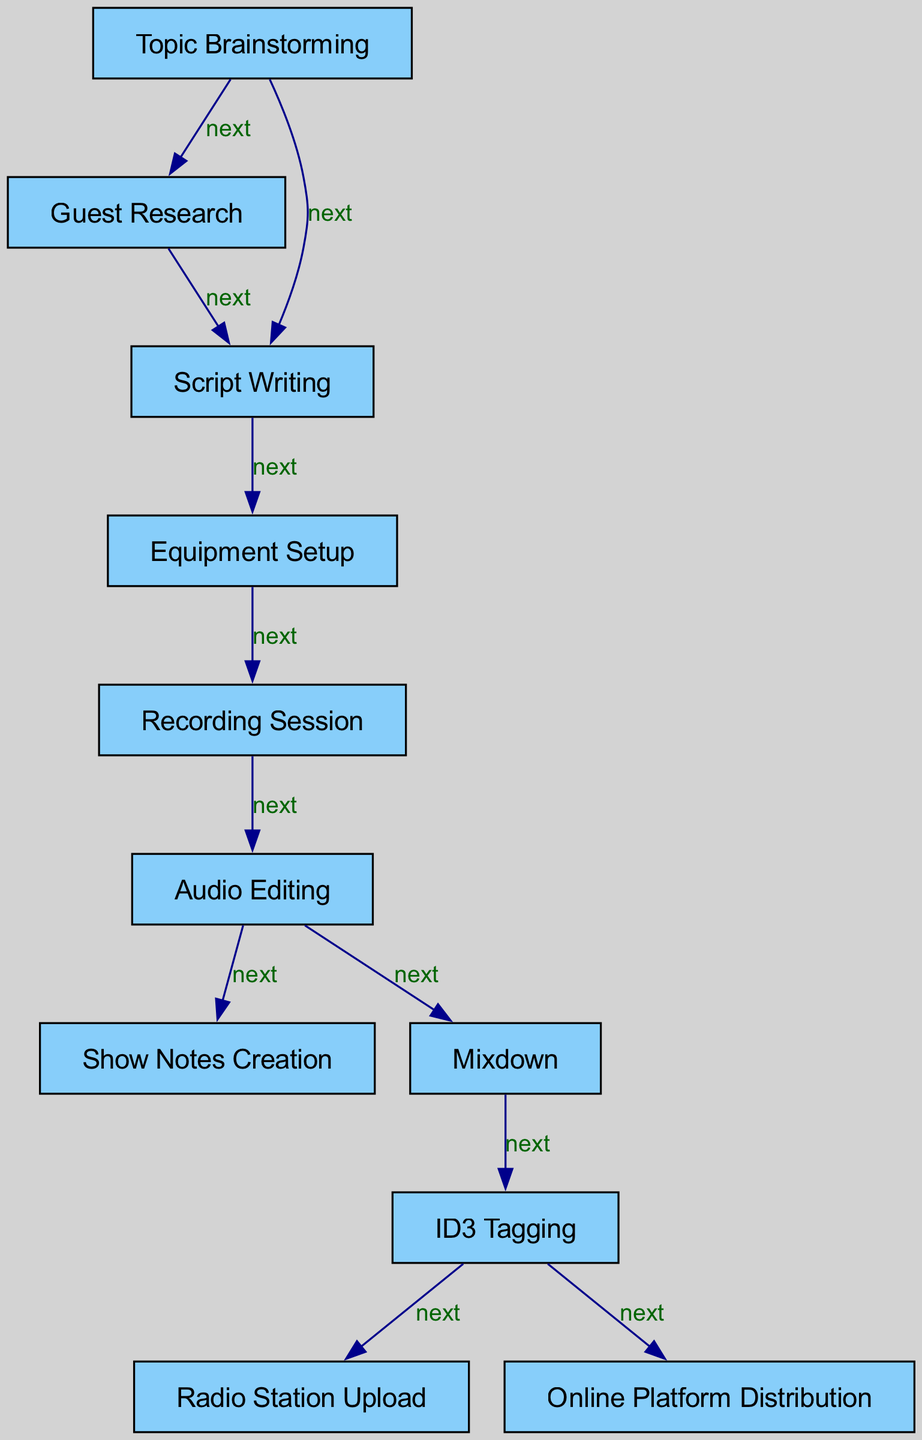What’s the total number of nodes in the diagram? To find the total number of nodes, we can simply count all the unique processes involved in the podcast production, which includes Topic Brainstorming, Guest Research, Script Writing, Equipment Setup, Recording Session, Audio Editing, Show Notes Creation, Mixdown, ID3 Tagging, Radio Station Upload, and Online Platform Distribution. Counting these gives us a total of 10 nodes.
Answer: 10 Which node comes after Audio Editing? By observing the directed edges in the diagram, we can see that Audio Editing leads to two nodes: Show Notes Creation and Mixdown. Thus, both are the next nodes that follow Audio Editing. However, if only one is required, we could mention the first one listed, which is Show Notes Creation.
Answer: Show Notes Creation How many edges are there in total? To determine the number of edges, we can count the directed connections that show the flow from one node to another. The edges include connections from Topic Brainstorming to Guest Research, Script Writing, Guest Research to Script Writing, and so on, up to Online Platform Distribution, counting all connections yields a total of 10 edges.
Answer: 10 What are the last two steps in the podcast production process? By examining the outgoing edges from the final node before distribution, which is ID3 Tagging, we see that it points to two outcomes: Radio Station Upload and Online Platform Distribution. Therefore, the last two steps are the processes directly attached to the ID3 Tagging node.
Answer: Radio Station Upload, Online Platform Distribution What is the first step in the process? The first step is determined by tracing the flow from the starting point. Looking at the diagram, the first node in the sequence is Topic Brainstorming. Therefore, Topic Brainstorming is the initial step in the podcast production process.
Answer: Topic Brainstorming Which node has the most outgoing edges? To find the node with the most outgoing edges, we must check how many connections each node has leading to other nodes. The node ID3 Tagging connects to two nodes: Radio Station Upload and Online Platform Distribution, whereas other nodes connect to fewer. Hence, ID3 Tagging has the most outgoing edges.
Answer: ID3 Tagging 